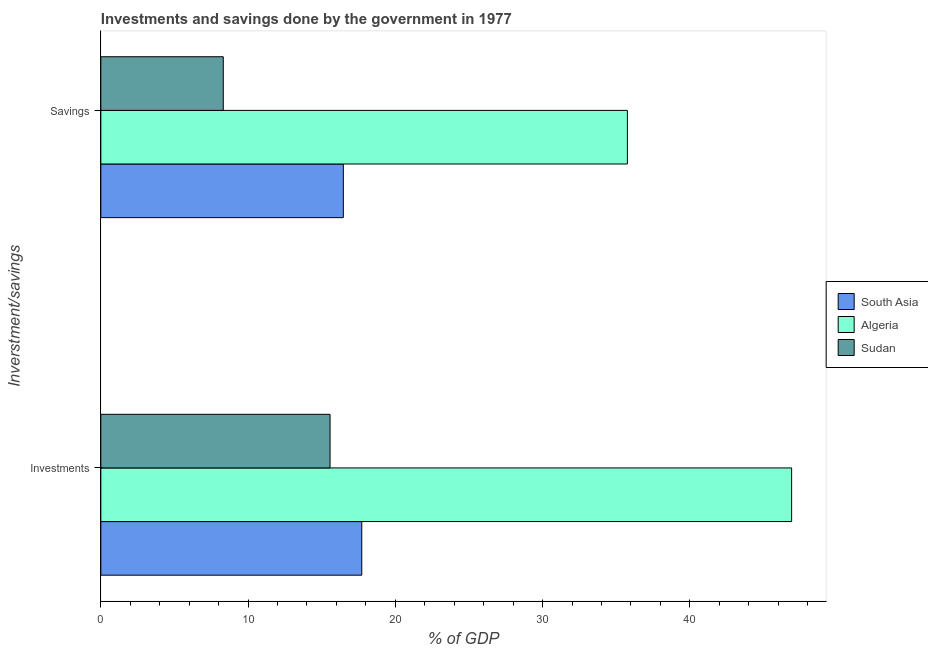How many different coloured bars are there?
Ensure brevity in your answer.  3. Are the number of bars on each tick of the Y-axis equal?
Ensure brevity in your answer.  Yes. How many bars are there on the 1st tick from the bottom?
Offer a terse response. 3. What is the label of the 2nd group of bars from the top?
Make the answer very short. Investments. What is the investments of government in Algeria?
Give a very brief answer. 46.91. Across all countries, what is the maximum investments of government?
Provide a short and direct response. 46.91. Across all countries, what is the minimum investments of government?
Offer a terse response. 15.57. In which country was the savings of government maximum?
Ensure brevity in your answer.  Algeria. In which country was the savings of government minimum?
Ensure brevity in your answer.  Sudan. What is the total savings of government in the graph?
Your answer should be compact. 60.54. What is the difference between the investments of government in Algeria and that in Sudan?
Your answer should be compact. 31.35. What is the difference between the savings of government in South Asia and the investments of government in Sudan?
Offer a terse response. 0.9. What is the average investments of government per country?
Offer a very short reply. 26.73. What is the difference between the investments of government and savings of government in South Asia?
Keep it short and to the point. 1.25. In how many countries, is the investments of government greater than 2 %?
Provide a short and direct response. 3. What is the ratio of the savings of government in Algeria to that in Sudan?
Your answer should be very brief. 4.3. Is the savings of government in South Asia less than that in Algeria?
Keep it short and to the point. Yes. What does the 2nd bar from the bottom in Investments represents?
Ensure brevity in your answer.  Algeria. How many bars are there?
Ensure brevity in your answer.  6. How many countries are there in the graph?
Your answer should be compact. 3. Are the values on the major ticks of X-axis written in scientific E-notation?
Offer a terse response. No. Does the graph contain grids?
Your response must be concise. No. How many legend labels are there?
Keep it short and to the point. 3. What is the title of the graph?
Offer a terse response. Investments and savings done by the government in 1977. What is the label or title of the X-axis?
Your response must be concise. % of GDP. What is the label or title of the Y-axis?
Your answer should be very brief. Inverstment/savings. What is the % of GDP in South Asia in Investments?
Your answer should be compact. 17.72. What is the % of GDP of Algeria in Investments?
Provide a succinct answer. 46.91. What is the % of GDP of Sudan in Investments?
Ensure brevity in your answer.  15.57. What is the % of GDP of South Asia in Savings?
Make the answer very short. 16.47. What is the % of GDP of Algeria in Savings?
Provide a short and direct response. 35.76. What is the % of GDP of Sudan in Savings?
Your answer should be compact. 8.31. Across all Inverstment/savings, what is the maximum % of GDP of South Asia?
Offer a terse response. 17.72. Across all Inverstment/savings, what is the maximum % of GDP in Algeria?
Offer a terse response. 46.91. Across all Inverstment/savings, what is the maximum % of GDP in Sudan?
Offer a very short reply. 15.57. Across all Inverstment/savings, what is the minimum % of GDP in South Asia?
Provide a short and direct response. 16.47. Across all Inverstment/savings, what is the minimum % of GDP in Algeria?
Your response must be concise. 35.76. Across all Inverstment/savings, what is the minimum % of GDP in Sudan?
Offer a very short reply. 8.31. What is the total % of GDP of South Asia in the graph?
Your response must be concise. 34.19. What is the total % of GDP in Algeria in the graph?
Your answer should be compact. 82.68. What is the total % of GDP in Sudan in the graph?
Give a very brief answer. 23.88. What is the difference between the % of GDP of South Asia in Investments and that in Savings?
Keep it short and to the point. 1.25. What is the difference between the % of GDP of Algeria in Investments and that in Savings?
Keep it short and to the point. 11.15. What is the difference between the % of GDP in Sudan in Investments and that in Savings?
Your answer should be very brief. 7.25. What is the difference between the % of GDP of South Asia in Investments and the % of GDP of Algeria in Savings?
Make the answer very short. -18.04. What is the difference between the % of GDP in South Asia in Investments and the % of GDP in Sudan in Savings?
Make the answer very short. 9.41. What is the difference between the % of GDP in Algeria in Investments and the % of GDP in Sudan in Savings?
Keep it short and to the point. 38.6. What is the average % of GDP in South Asia per Inverstment/savings?
Your response must be concise. 17.1. What is the average % of GDP of Algeria per Inverstment/savings?
Offer a very short reply. 41.34. What is the average % of GDP of Sudan per Inverstment/savings?
Ensure brevity in your answer.  11.94. What is the difference between the % of GDP in South Asia and % of GDP in Algeria in Investments?
Your response must be concise. -29.19. What is the difference between the % of GDP in South Asia and % of GDP in Sudan in Investments?
Your answer should be compact. 2.15. What is the difference between the % of GDP in Algeria and % of GDP in Sudan in Investments?
Your response must be concise. 31.35. What is the difference between the % of GDP of South Asia and % of GDP of Algeria in Savings?
Make the answer very short. -19.29. What is the difference between the % of GDP in South Asia and % of GDP in Sudan in Savings?
Give a very brief answer. 8.15. What is the difference between the % of GDP of Algeria and % of GDP of Sudan in Savings?
Make the answer very short. 27.45. What is the ratio of the % of GDP in South Asia in Investments to that in Savings?
Give a very brief answer. 1.08. What is the ratio of the % of GDP in Algeria in Investments to that in Savings?
Your response must be concise. 1.31. What is the ratio of the % of GDP of Sudan in Investments to that in Savings?
Offer a very short reply. 1.87. What is the difference between the highest and the second highest % of GDP in South Asia?
Ensure brevity in your answer.  1.25. What is the difference between the highest and the second highest % of GDP in Algeria?
Your response must be concise. 11.15. What is the difference between the highest and the second highest % of GDP in Sudan?
Your response must be concise. 7.25. What is the difference between the highest and the lowest % of GDP of South Asia?
Offer a very short reply. 1.25. What is the difference between the highest and the lowest % of GDP of Algeria?
Make the answer very short. 11.15. What is the difference between the highest and the lowest % of GDP in Sudan?
Your response must be concise. 7.25. 